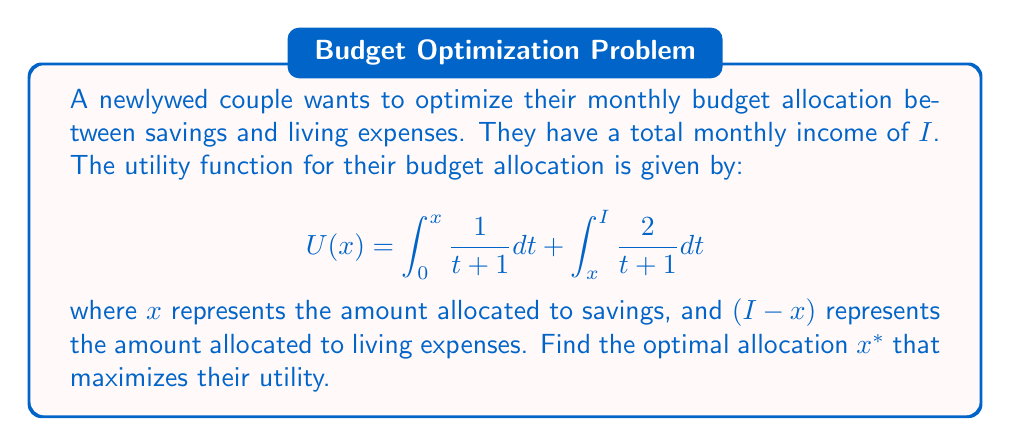What is the answer to this math problem? To find the optimal allocation, we need to maximize the utility function $U(x)$. This can be done by finding the value of $x$ where the derivative of $U(x)$ is zero.

Step 1: Calculate $U'(x)$ using the Fundamental Theorem of Calculus:
$$U'(x) = \frac{1}{x+1} - \frac{2}{x+1} = -\frac{1}{x+1}$$

Step 2: Set $U'(x) = 0$ and solve for $x$:
$$-\frac{1}{x+1} = 0$$
$$x + 1 = \infty$$

This solution is not feasible, so we need to consider the endpoints of the interval $[0, I]$.

Step 3: Evaluate $U(x)$ at $x = 0$ and $x = I$:

At $x = 0$:
$$U(0) = 0 + \int_0^I \frac{2}{t+1} dt = 2\ln(I+1)$$

At $x = I$:
$$U(I) = \int_0^I \frac{1}{t+1} dt + 0 = \ln(I+1)$$

Step 4: Compare $U(0)$ and $U(I)$:
$$U(0) = 2\ln(I+1) > \ln(I+1) = U(I)$$

Therefore, the utility is maximized when $x = 0$, meaning the couple should allocate all their income to living expenses and none to savings.
Answer: $x^* = 0$ (allocate all income to living expenses) 